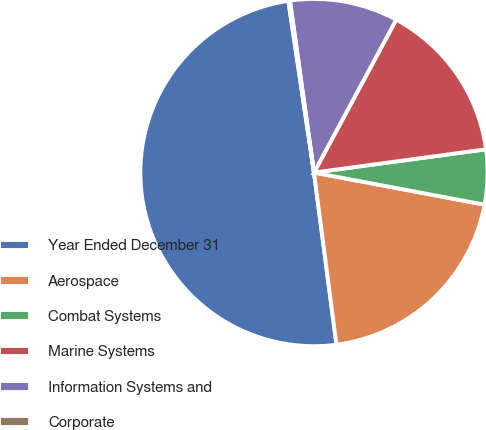<chart> <loc_0><loc_0><loc_500><loc_500><pie_chart><fcel>Year Ended December 31<fcel>Aerospace<fcel>Combat Systems<fcel>Marine Systems<fcel>Information Systems and<fcel>Corporate<nl><fcel>49.7%<fcel>19.97%<fcel>5.1%<fcel>15.01%<fcel>10.06%<fcel>0.15%<nl></chart> 